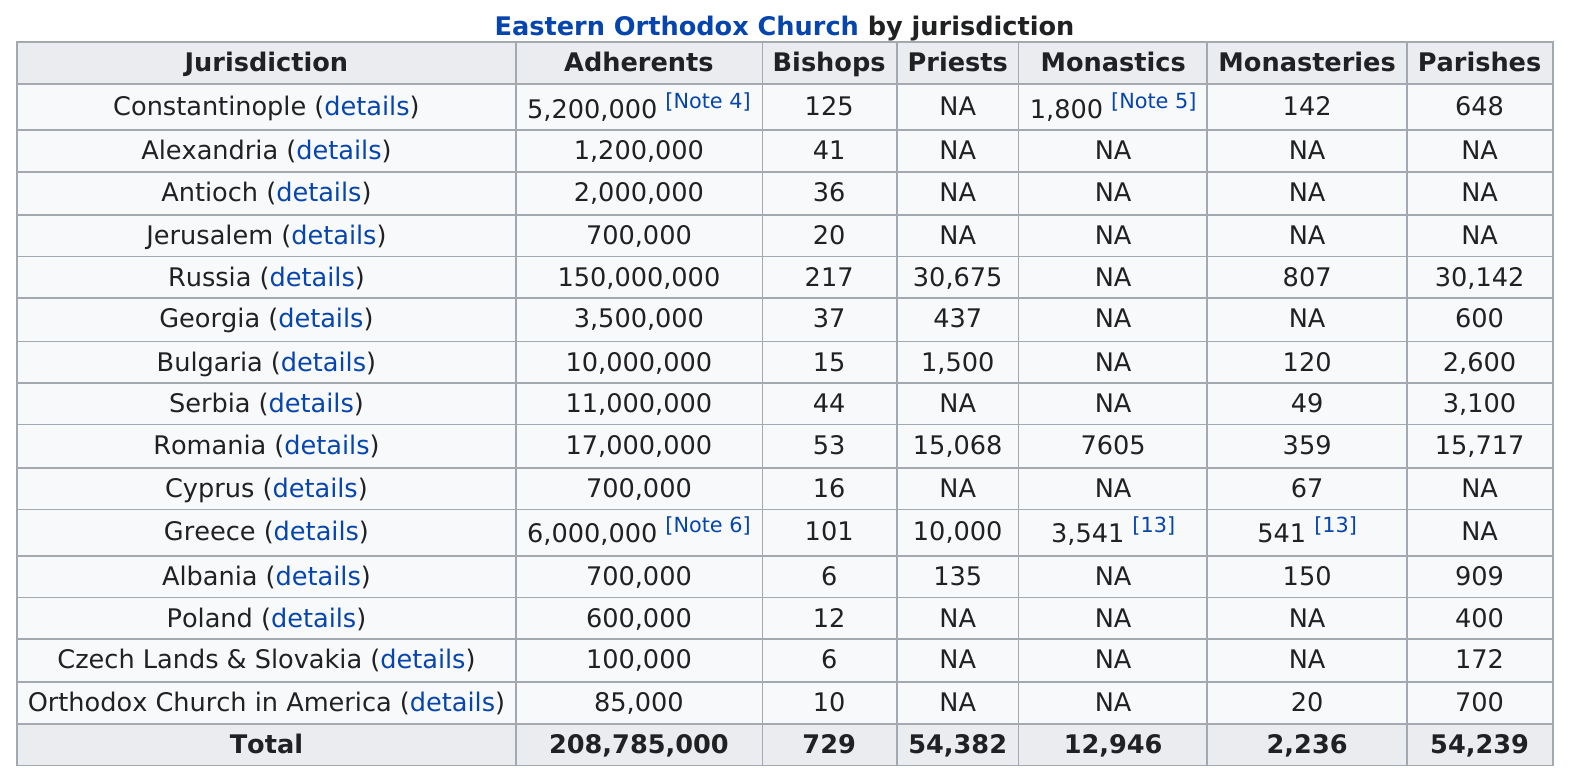Point out several critical features in this image. Jerusalem has the same number of adherents as Cyprus. Russia has the largest number of adherents. In Serbia, there are 0.000004 bishops per adherent. There are 15 jurisdictions listed in the chart according to my count. Constantinople currently has 4500000 more adherents than Jerusalem, 